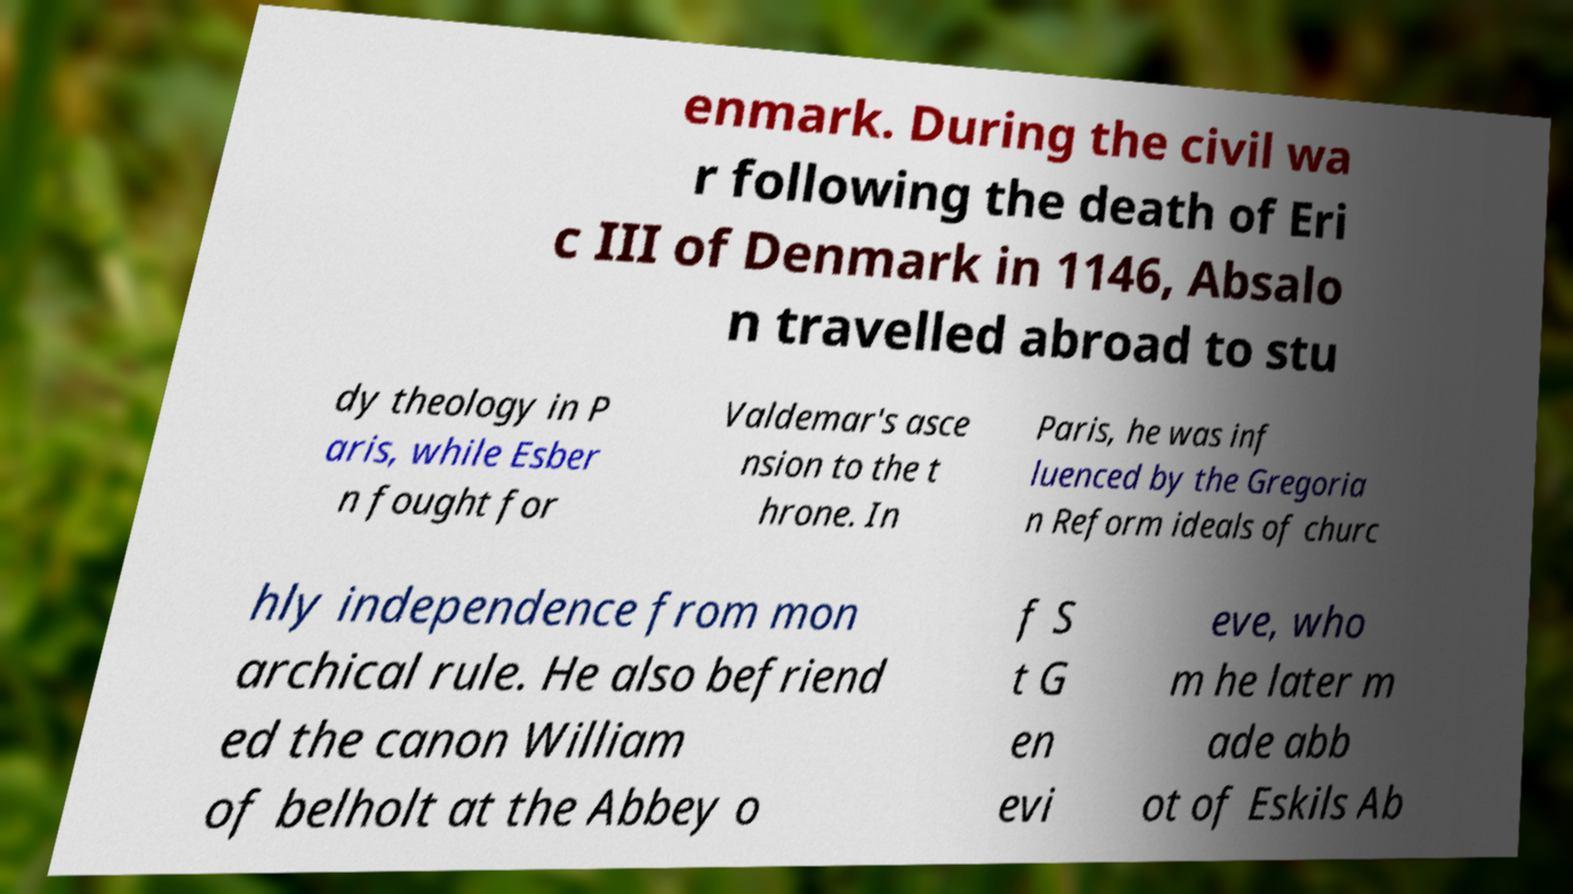There's text embedded in this image that I need extracted. Can you transcribe it verbatim? enmark. During the civil wa r following the death of Eri c III of Denmark in 1146, Absalo n travelled abroad to stu dy theology in P aris, while Esber n fought for Valdemar's asce nsion to the t hrone. In Paris, he was inf luenced by the Gregoria n Reform ideals of churc hly independence from mon archical rule. He also befriend ed the canon William of belholt at the Abbey o f S t G en evi eve, who m he later m ade abb ot of Eskils Ab 